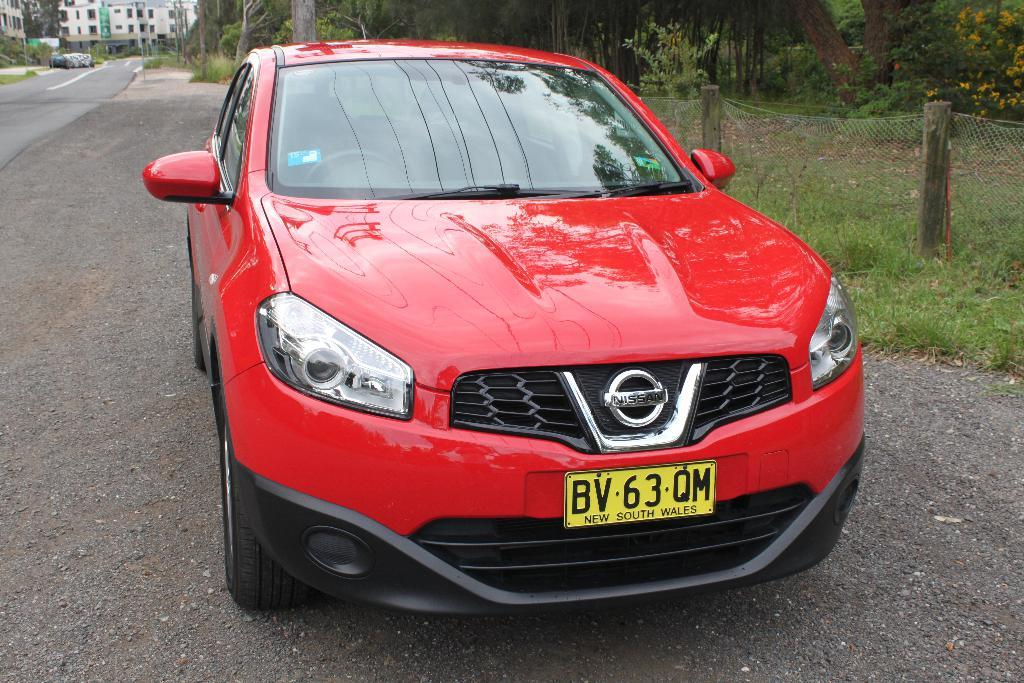What is the main subject of the image? There is a car in the middle of the image. What is located at the bottom of the image? There is a road at the bottom of the image. What can be seen in the background of the image? There are trees, buildings, a fence, grass, plants, and flowers visible in the background of the image. Is there any steam coming out of the car's exhaust in the image? There is no mention of steam or any exhaust in the image, so it cannot be determined from the provided facts. Can you see any bats flying around the car in the image? There is no mention of bats or any animals in the image, so it cannot be determined from the provided facts. 